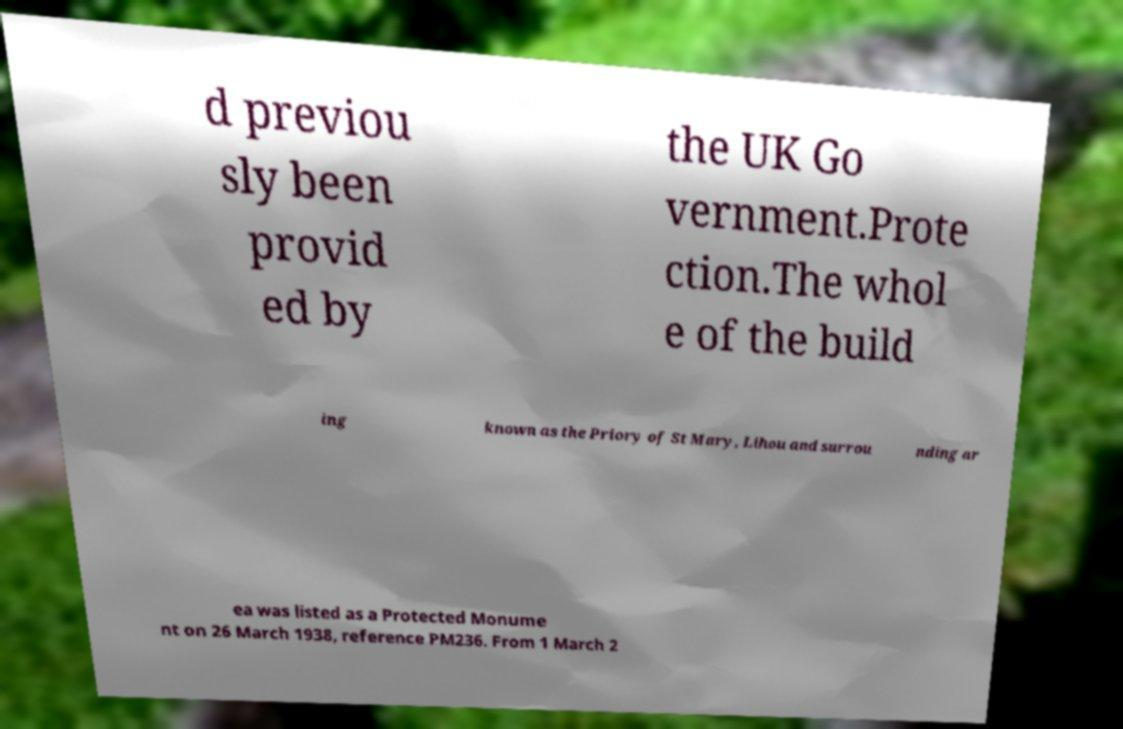I need the written content from this picture converted into text. Can you do that? d previou sly been provid ed by the UK Go vernment.Prote ction.The whol e of the build ing known as the Priory of St Mary, Lihou and surrou nding ar ea was listed as a Protected Monume nt on 26 March 1938, reference PM236. From 1 March 2 